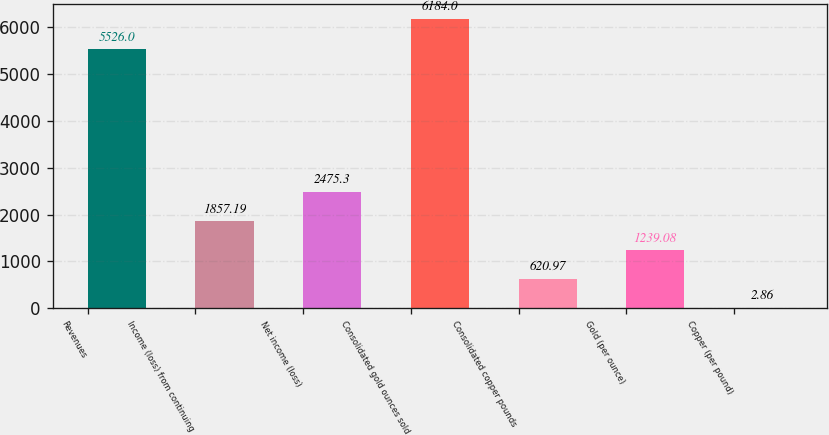Convert chart to OTSL. <chart><loc_0><loc_0><loc_500><loc_500><bar_chart><fcel>Revenues<fcel>Income (loss) from continuing<fcel>Net income (loss)<fcel>Consolidated gold ounces sold<fcel>Consolidated copper pounds<fcel>Gold (per ounce)<fcel>Copper (per pound)<nl><fcel>5526<fcel>1857.19<fcel>2475.3<fcel>6184<fcel>620.97<fcel>1239.08<fcel>2.86<nl></chart> 